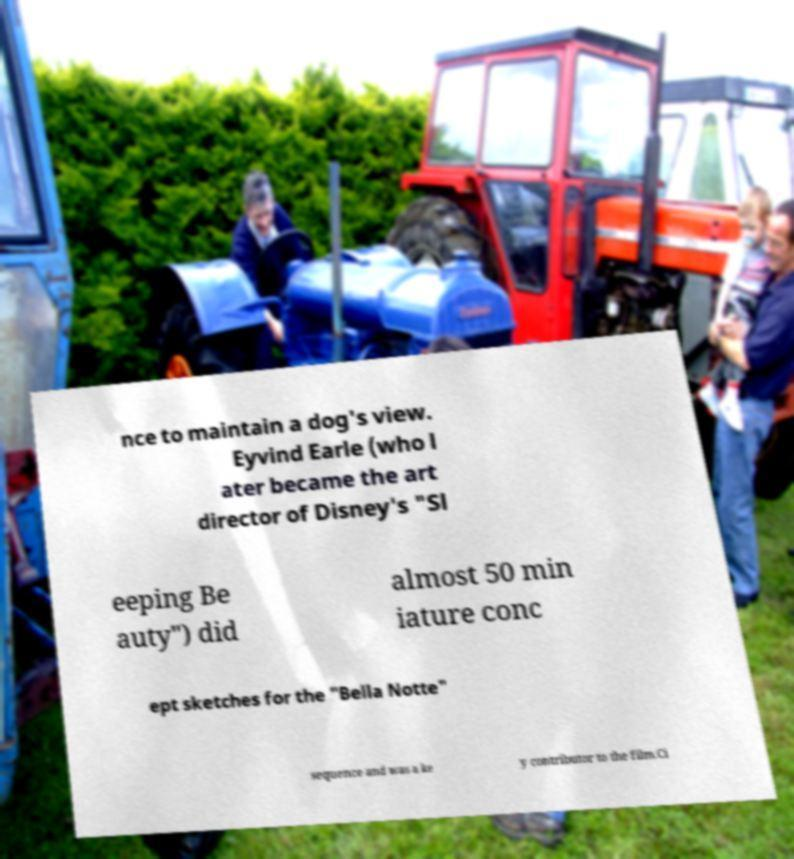Could you extract and type out the text from this image? nce to maintain a dog's view. Eyvind Earle (who l ater became the art director of Disney's "Sl eeping Be auty") did almost 50 min iature conc ept sketches for the "Bella Notte" sequence and was a ke y contributor to the film.Ci 